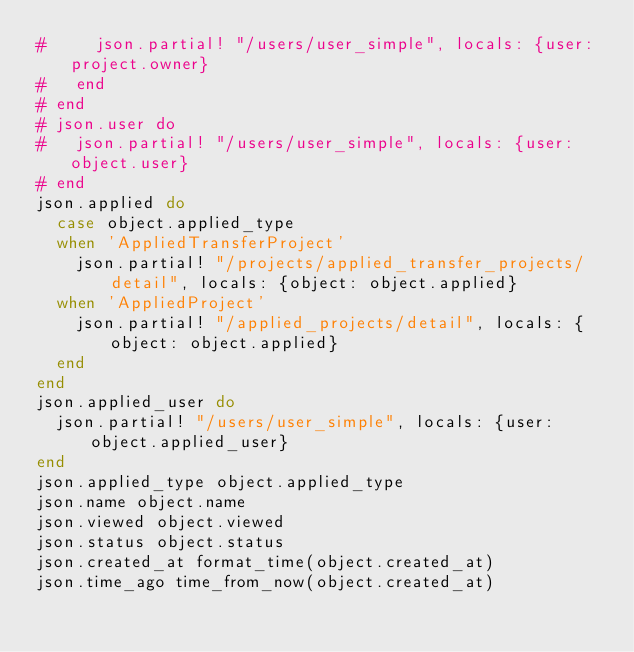Convert code to text. <code><loc_0><loc_0><loc_500><loc_500><_Ruby_>#     json.partial! "/users/user_simple", locals: {user: project.owner}
#   end
# end
# json.user do 
#   json.partial! "/users/user_simple", locals: {user: object.user}
# end
json.applied do 
  case object.applied_type 
  when 'AppliedTransferProject'
    json.partial! "/projects/applied_transfer_projects/detail", locals: {object: object.applied}
  when 'AppliedProject'
    json.partial! "/applied_projects/detail", locals: {object: object.applied}
  end
end
json.applied_user do 
  json.partial! "/users/user_simple", locals: {user: object.applied_user}
end
json.applied_type object.applied_type
json.name object.name
json.viewed object.viewed
json.status object.status
json.created_at format_time(object.created_at)
json.time_ago time_from_now(object.created_at)
</code> 